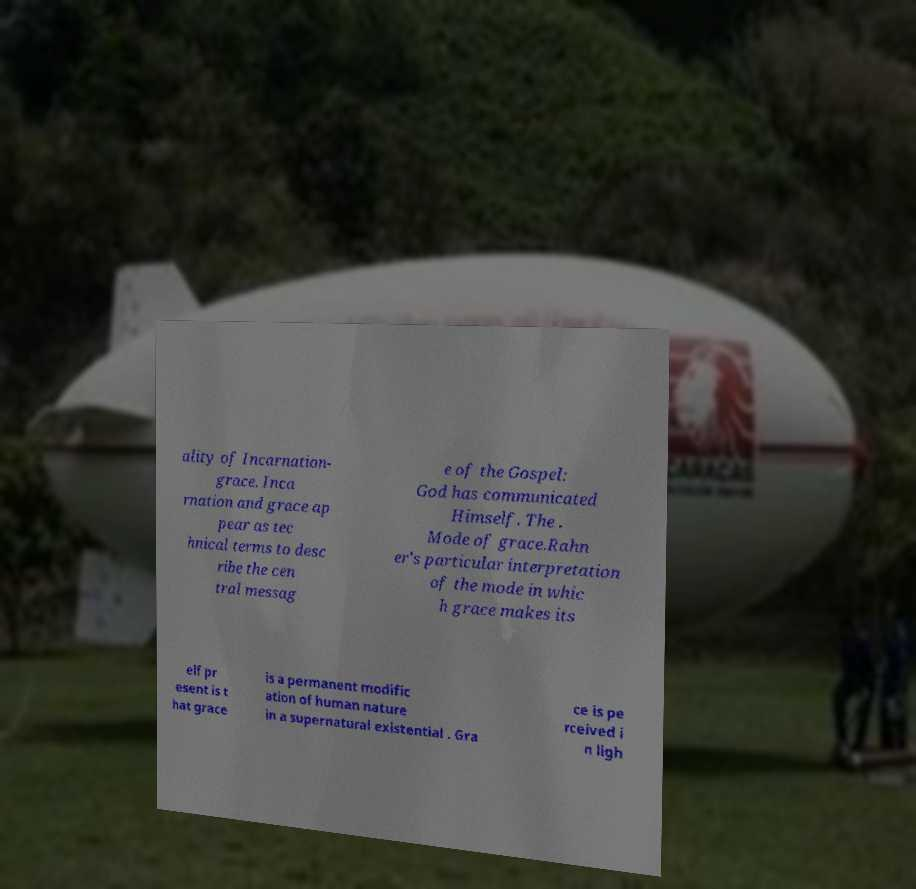There's text embedded in this image that I need extracted. Can you transcribe it verbatim? ality of Incarnation- grace. Inca rnation and grace ap pear as tec hnical terms to desc ribe the cen tral messag e of the Gospel: God has communicated Himself. The . Mode of grace.Rahn er's particular interpretation of the mode in whic h grace makes its elf pr esent is t hat grace is a permanent modific ation of human nature in a supernatural existential . Gra ce is pe rceived i n ligh 